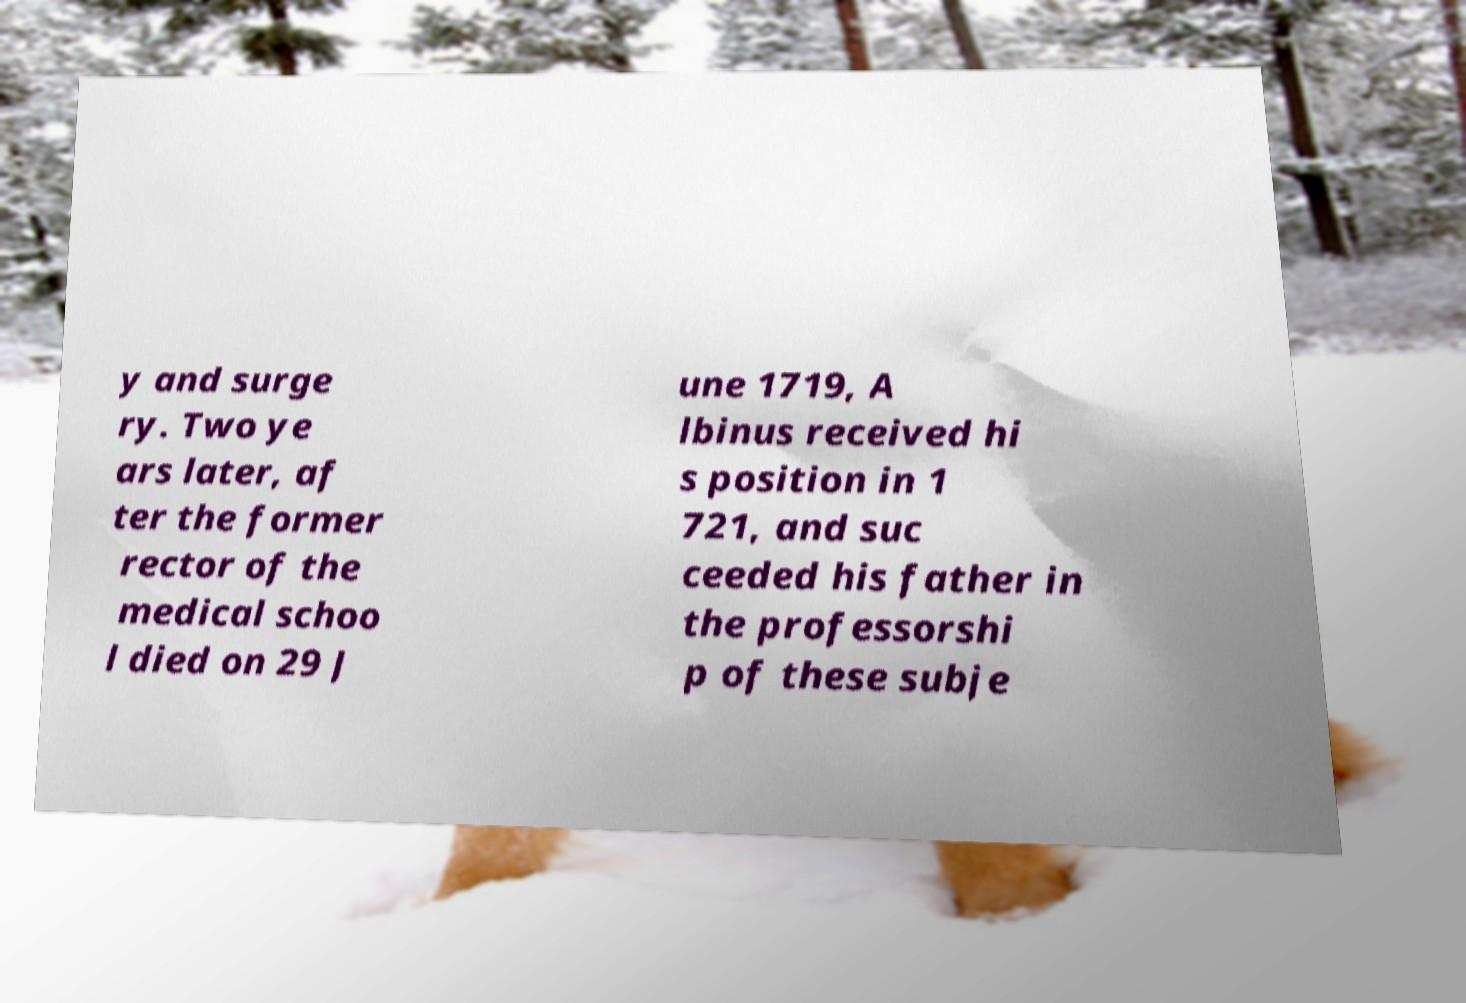Could you extract and type out the text from this image? y and surge ry. Two ye ars later, af ter the former rector of the medical schoo l died on 29 J une 1719, A lbinus received hi s position in 1 721, and suc ceeded his father in the professorshi p of these subje 